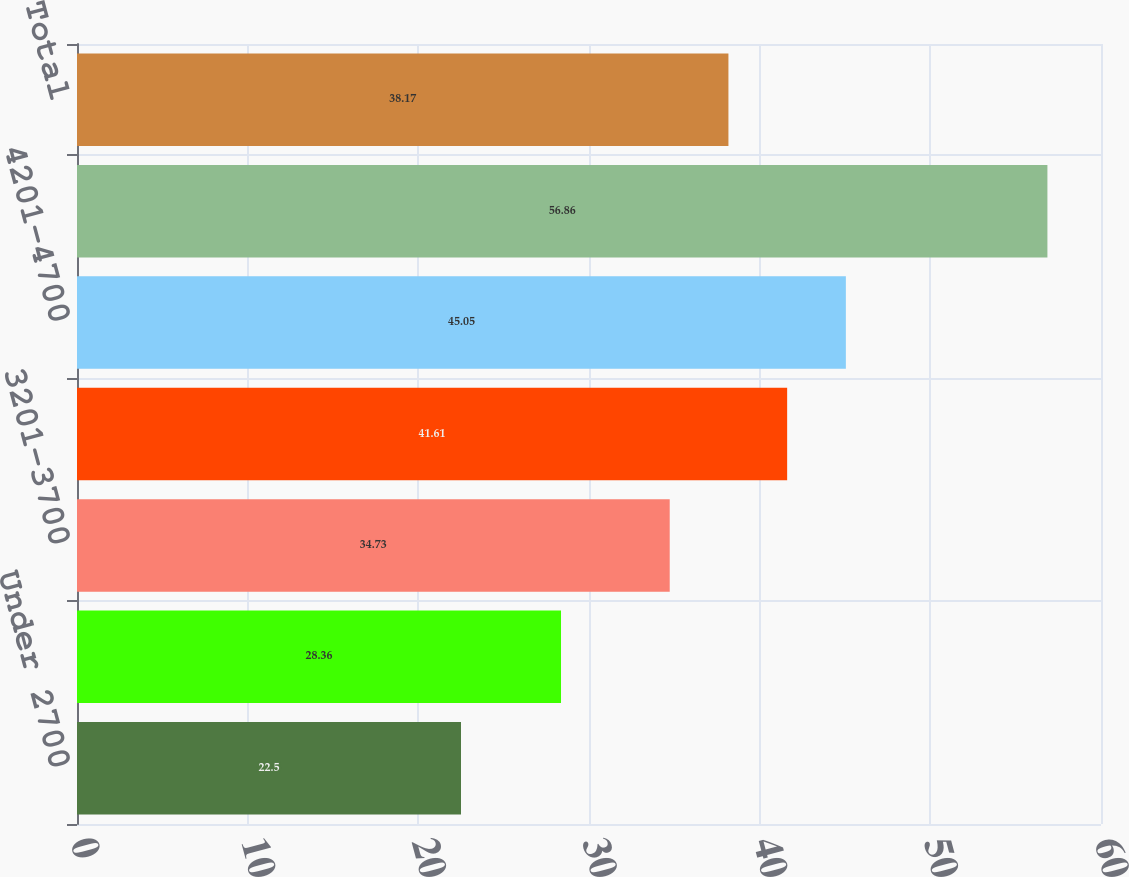Convert chart to OTSL. <chart><loc_0><loc_0><loc_500><loc_500><bar_chart><fcel>Under 2700<fcel>2701-3200<fcel>3201-3700<fcel>3701-4200<fcel>4201-4700<fcel>Over 4700<fcel>Total<nl><fcel>22.5<fcel>28.36<fcel>34.73<fcel>41.61<fcel>45.05<fcel>56.86<fcel>38.17<nl></chart> 